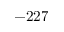Convert formula to latex. <formula><loc_0><loc_0><loc_500><loc_500>- 2 2 7</formula> 